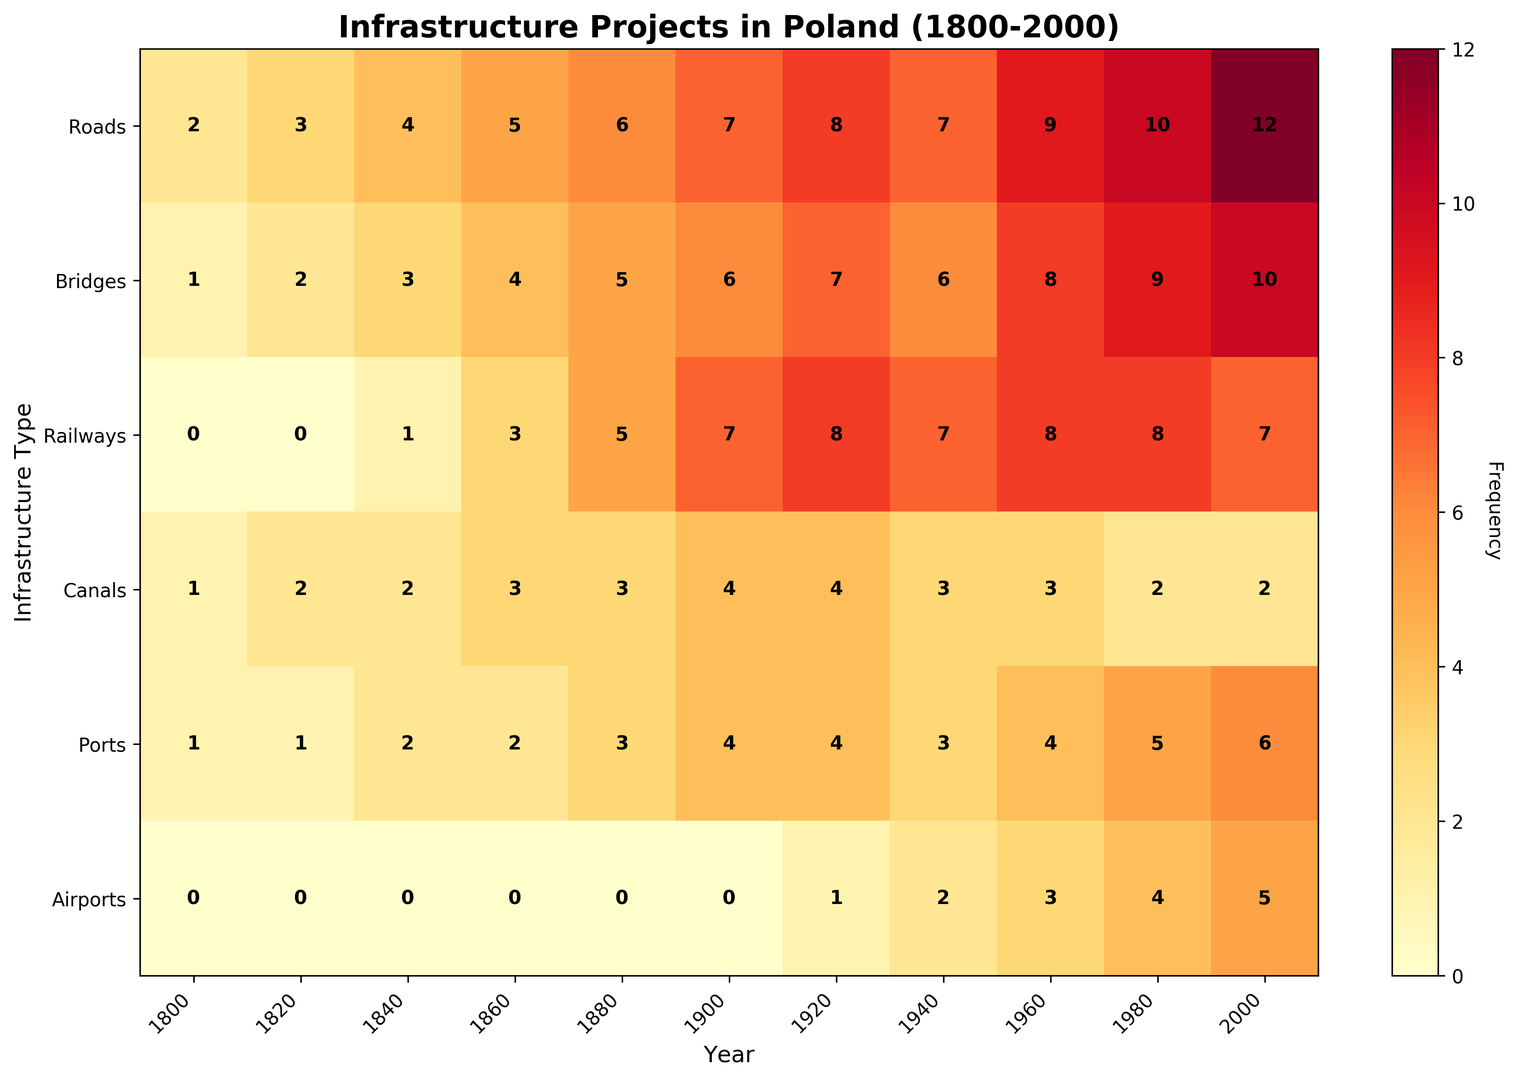What type of infrastructure had the highest frequency in the year 2000? Look at the year 2000 column and identify the maximum value. The highest value is 12 under Roads.
Answer: Roads How did the frequency of railways change from 1800 to 2000? Compare the frequency values of railways in 1800 and 2000. In 1800, it was 0, and in 2000, it was 7.
Answer: Increased from 0 to 7 What's the combined frequency of Bridges and Canals in the year 1840? Sum the frequencies of Bridges and Canals in the year 1840. Bridges = 3, Canals = 2, so 3 + 2 = 5
Answer: 5 Which period shows the highest frequency for Airports? Check the column for Airports and identify the maximum value and its corresponding year. The highest value is 5 in 2000.
Answer: 2000 Is there a period where Ports and Airports have the same frequency? If yes, which period? Compare the values of Ports and Airports across all years. The value is the same (4) in 1920.
Answer: 1920 What is the average frequency of Roads across the given periods? Sum the frequencies of Roads (2+3+4+5+6+7+8+7+9+10+12 = 73) and divide by the number of periods (11). The average is 73/11 ≈ 6.64
Answer: 6.64 In which year did the frequency of Roads surpass that of Bridges for the first time? Compare the values of Roads and Bridges year by year. Roads surpassed Bridges for the first time in 1840 (4 > 3).
Answer: 1840 Which two years had the highest combined frequency of all infrastructure projects? Sum the values for each year and compare. 
For 1960: 9+8+8+3+4+3 = 35
For 2000: 12+10+7+2+6+5 = 42
The years 1960 and 2000 had the highest combined frequencies, with 35 and 42, respectively.
Answer: 1960 and 2000 In 1880, what is the ratio of the frequency of Roads to Railways? Compare the values of Roads and Railways in 1880. Roads = 6, Railways = 5. The ratio is 6:5.
Answer: 6:5 How did the frequency of Bridges change between 1880 and 1980? Compare the values of Bridges in 1880 and 1980. In 1880, it was 5, and in 1980, it was 9.
Answer: Increased from 5 to 9 